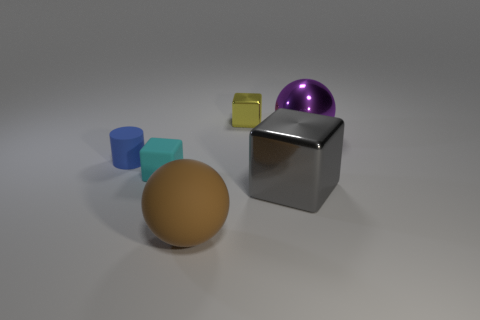What number of tiny cyan rubber objects are there?
Give a very brief answer. 1. There is a small thing that is to the right of the brown ball; what shape is it?
Make the answer very short. Cube. There is a large ball that is to the right of the sphere that is on the left side of the small thing that is behind the blue matte cylinder; what color is it?
Provide a short and direct response. Purple. There is a brown object that is the same material as the cyan object; what is its shape?
Provide a short and direct response. Sphere. Is the number of tiny yellow blocks less than the number of large green cylinders?
Give a very brief answer. No. Are the big gray thing and the tiny yellow block made of the same material?
Your answer should be very brief. Yes. How many other objects are there of the same color as the small metallic block?
Give a very brief answer. 0. Is the number of gray metallic objects greater than the number of cyan metal objects?
Offer a very short reply. Yes. There is a matte sphere; does it have the same size as the cube that is on the left side of the matte sphere?
Keep it short and to the point. No. There is a cube behind the purple thing; what color is it?
Offer a very short reply. Yellow. 